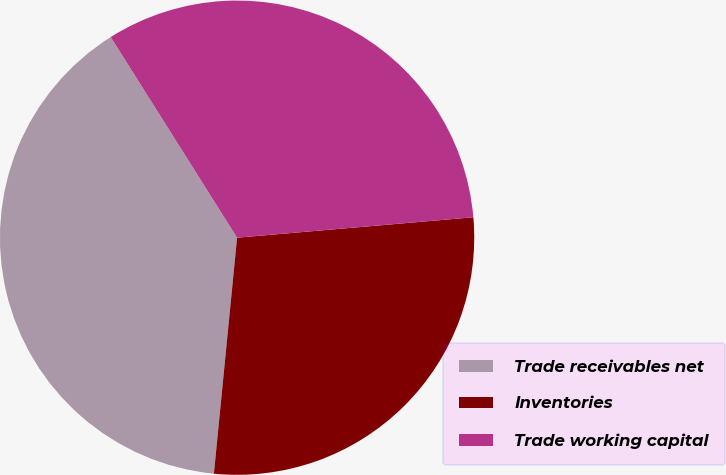<chart> <loc_0><loc_0><loc_500><loc_500><pie_chart><fcel>Trade receivables net<fcel>Inventories<fcel>Trade working capital<nl><fcel>39.49%<fcel>27.93%<fcel>32.57%<nl></chart> 